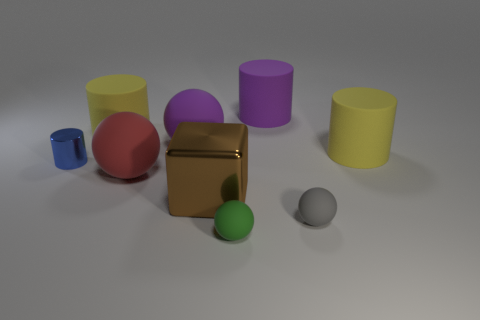What material does the cube seem to be made of? The cube appears to be made of a reflective, metallic material, likely gold or a gold-colored alloy, given its lustrous, mirror-like finish. Is there anything unique about its position compared to the other objects? Indeed, the cube's placement at the center of the arrangement makes it a focal point amidst the other objects, underscored by its reflective surface that catches light distinctively. 